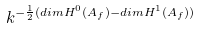Convert formula to latex. <formula><loc_0><loc_0><loc_500><loc_500>k ^ { - \frac { 1 } { 2 } ( d i m H ^ { 0 } ( A _ { f } ) - d i m H ^ { 1 } ( A _ { f } ) ) }</formula> 